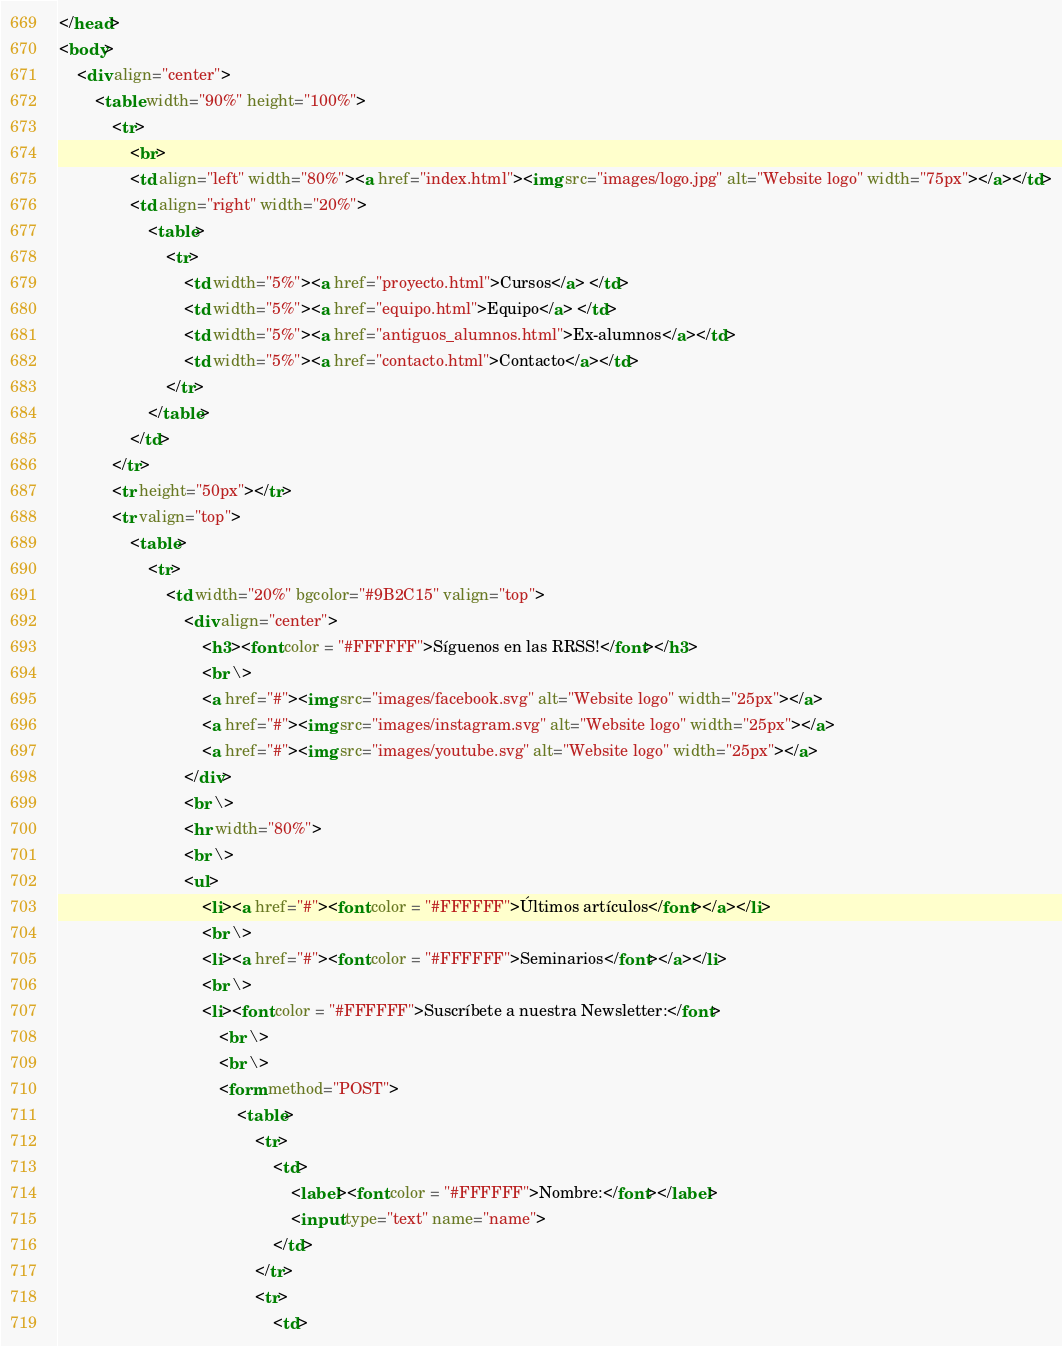<code> <loc_0><loc_0><loc_500><loc_500><_HTML_></head>
<body>
    <div align="center">
        <table width="90%" height="100%">
            <tr>
                <br>
                <td align="left" width="80%"><a href="index.html"><img src="images/logo.jpg" alt="Website logo" width="75px"></a></td>
                <td align="right" width="20%">
                    <table>
                        <tr>
                            <td width="5%"><a href="proyecto.html">Cursos</a> </td>
                            <td width="5%"><a href="equipo.html">Equipo</a> </td>
                            <td width="5%"><a href="antiguos_alumnos.html">Ex-alumnos</a></td>
                            <td width="5%"><a href="contacto.html">Contacto</a></td>
                        </tr>
                    </table>
                </td>
            </tr>
            <tr height="50px"></tr>
            <tr valign="top">
                <table>
                    <tr>
                        <td width="20%" bgcolor="#9B2C15" valign="top">
                            <div align="center">
                                <h3><font color = "#FFFFFF">Síguenos en las RRSS!</font></h3>
                                <br \>
                                <a href="#"><img src="images/facebook.svg" alt="Website logo" width="25px"></a>
                                <a href="#"><img src="images/instagram.svg" alt="Website logo" width="25px"></a>
                                <a href="#"><img src="images/youtube.svg" alt="Website logo" width="25px"></a>
                            </div>
                            <br \>
                            <hr width="80%">
                            <br \>
                            <ul>
                                <li><a href="#"><font color = "#FFFFFF">Últimos artículos</font></a></li>
                                <br \>
                                <li><a href="#"><font color = "#FFFFFF">Seminarios</font></a></li>
                                <br \>
                                <li><font color = "#FFFFFF">Suscríbete a nuestra Newsletter:</font>
                                    <br \>
                                    <br \>
                                    <form method="POST">
                                        <table>
                                            <tr>
                                                <td>
                                                    <label><font color = "#FFFFFF">Nombre:</font></label>
                                                    <input type="text" name="name">
                                                </td>
                                            </tr>
                                            <tr>
                                                <td></code> 